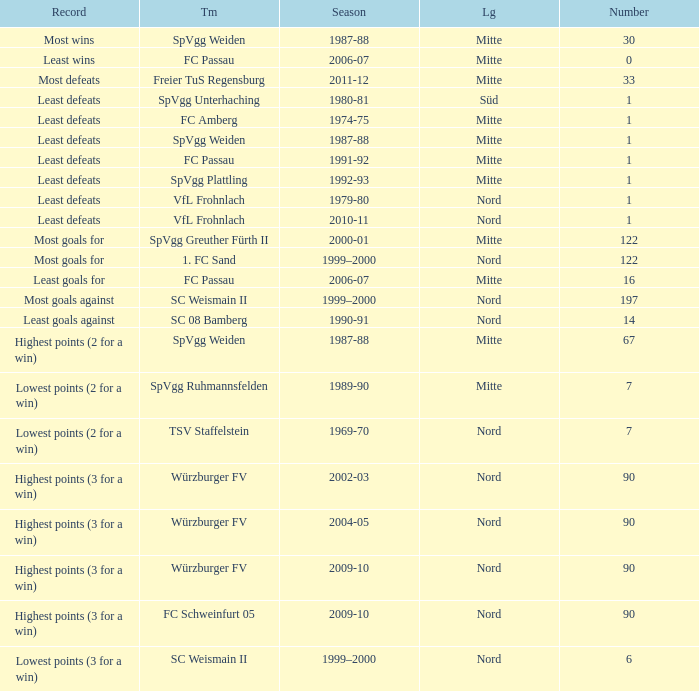What season has a number less than 90, Mitte as the league and spvgg ruhmannsfelden as the team? 1989-90. Write the full table. {'header': ['Record', 'Tm', 'Season', 'Lg', 'Number'], 'rows': [['Most wins', 'SpVgg Weiden', '1987-88', 'Mitte', '30'], ['Least wins', 'FC Passau', '2006-07', 'Mitte', '0'], ['Most defeats', 'Freier TuS Regensburg', '2011-12', 'Mitte', '33'], ['Least defeats', 'SpVgg Unterhaching', '1980-81', 'Süd', '1'], ['Least defeats', 'FC Amberg', '1974-75', 'Mitte', '1'], ['Least defeats', 'SpVgg Weiden', '1987-88', 'Mitte', '1'], ['Least defeats', 'FC Passau', '1991-92', 'Mitte', '1'], ['Least defeats', 'SpVgg Plattling', '1992-93', 'Mitte', '1'], ['Least defeats', 'VfL Frohnlach', '1979-80', 'Nord', '1'], ['Least defeats', 'VfL Frohnlach', '2010-11', 'Nord', '1'], ['Most goals for', 'SpVgg Greuther Fürth II', '2000-01', 'Mitte', '122'], ['Most goals for', '1. FC Sand', '1999–2000', 'Nord', '122'], ['Least goals for', 'FC Passau', '2006-07', 'Mitte', '16'], ['Most goals against', 'SC Weismain II', '1999–2000', 'Nord', '197'], ['Least goals against', 'SC 08 Bamberg', '1990-91', 'Nord', '14'], ['Highest points (2 for a win)', 'SpVgg Weiden', '1987-88', 'Mitte', '67'], ['Lowest points (2 for a win)', 'SpVgg Ruhmannsfelden', '1989-90', 'Mitte', '7'], ['Lowest points (2 for a win)', 'TSV Staffelstein', '1969-70', 'Nord', '7'], ['Highest points (3 for a win)', 'Würzburger FV', '2002-03', 'Nord', '90'], ['Highest points (3 for a win)', 'Würzburger FV', '2004-05', 'Nord', '90'], ['Highest points (3 for a win)', 'Würzburger FV', '2009-10', 'Nord', '90'], ['Highest points (3 for a win)', 'FC Schweinfurt 05', '2009-10', 'Nord', '90'], ['Lowest points (3 for a win)', 'SC Weismain II', '1999–2000', 'Nord', '6']]} 